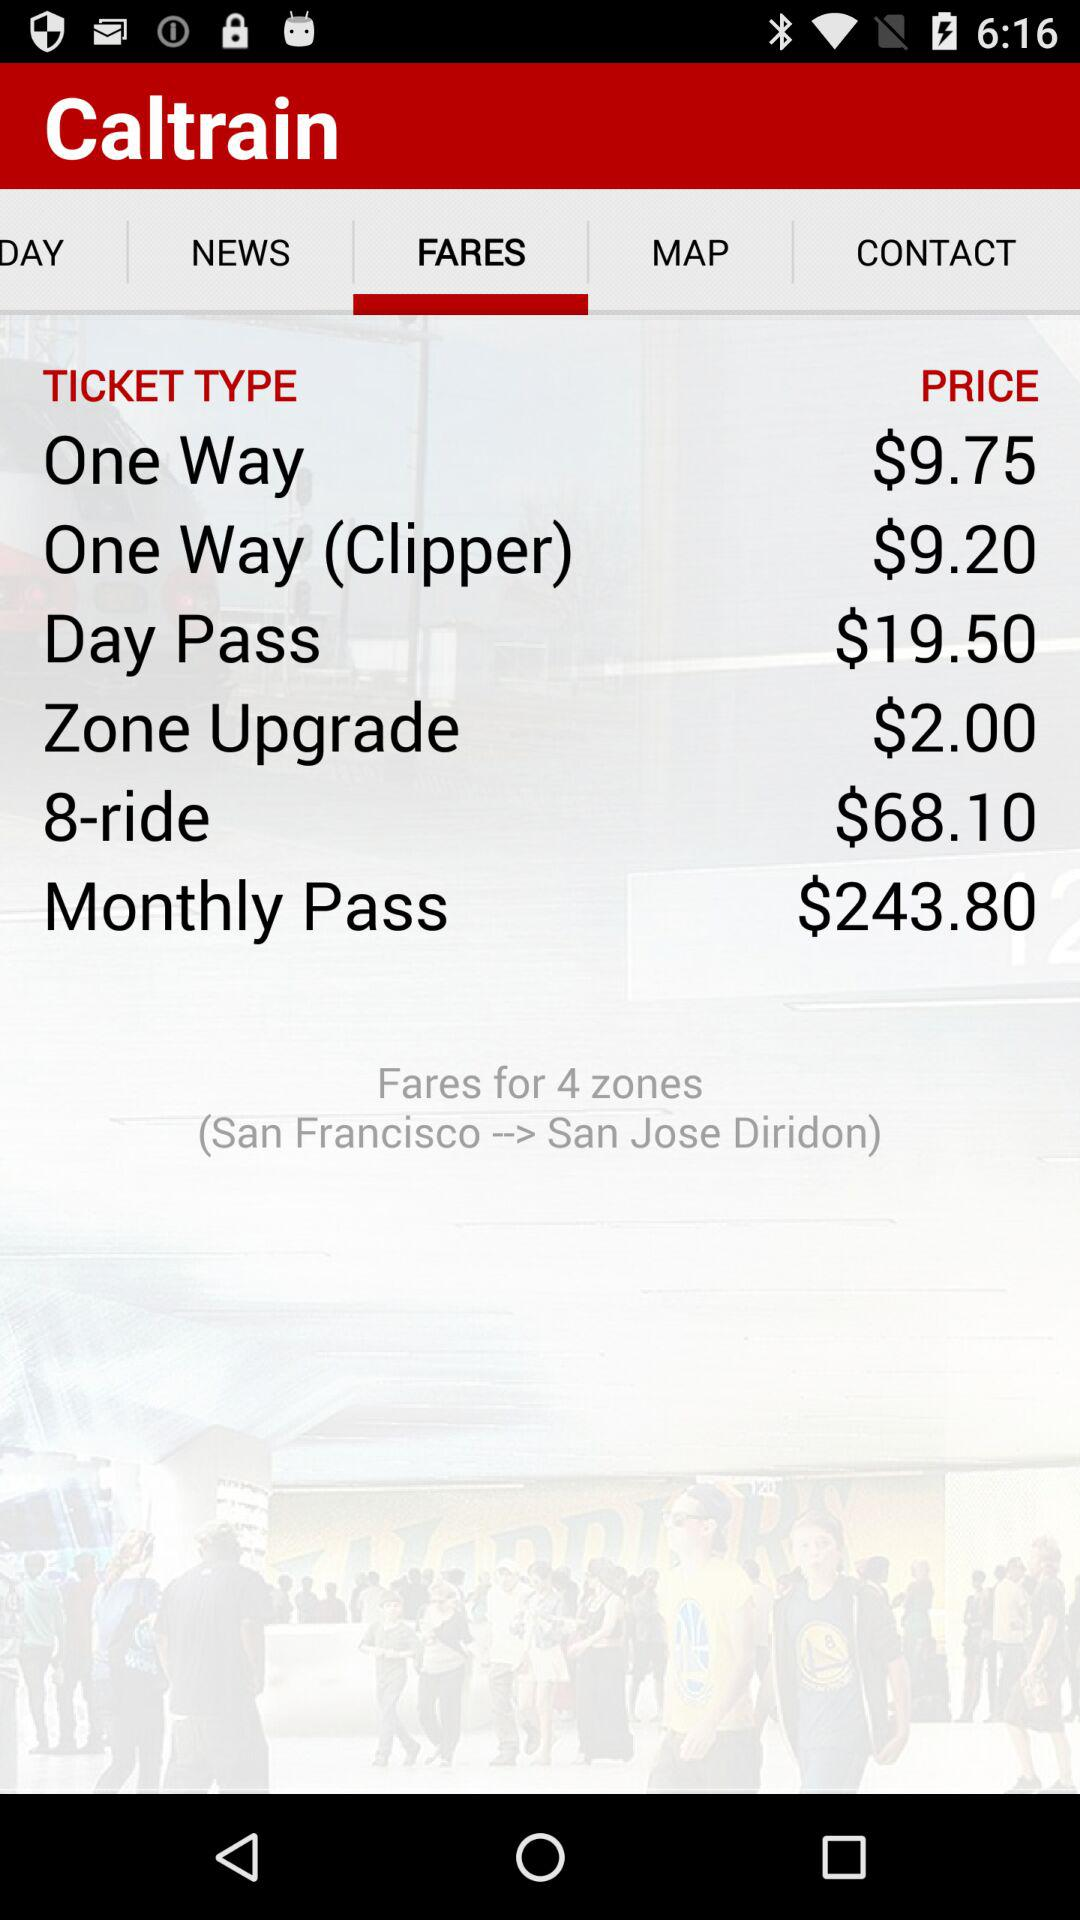How much is the price of a monthly pass? The price of a monthly pass is $243.80. 